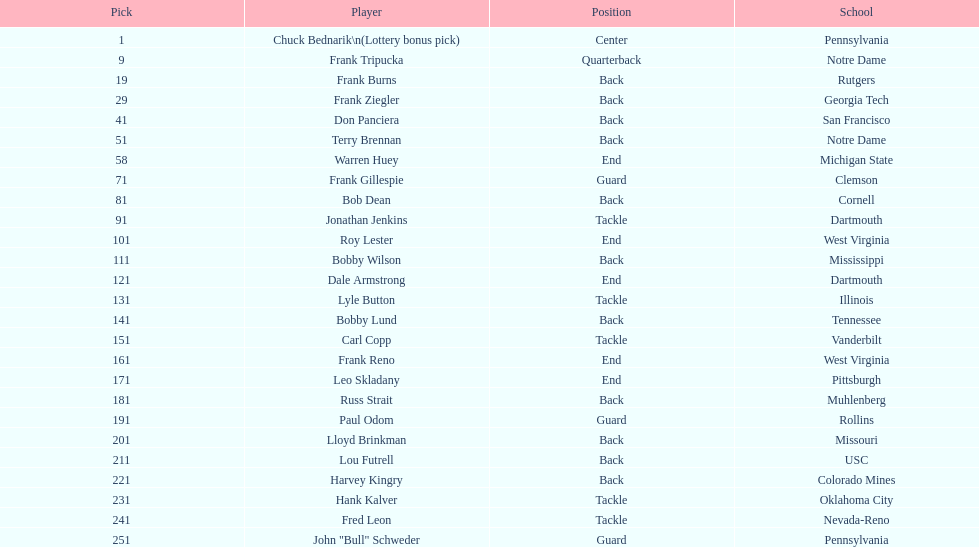How many draft picks were between frank tripucka and dale armstrong? 10. 